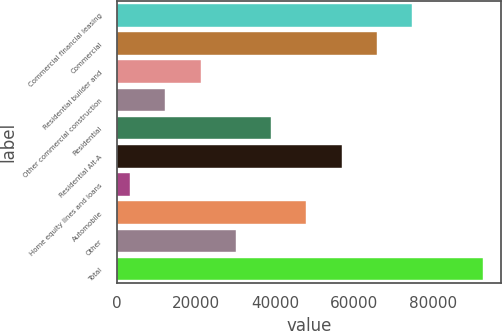<chart> <loc_0><loc_0><loc_500><loc_500><bar_chart><fcel>Commercial financial leasing<fcel>Commercial<fcel>Residential builder and<fcel>Other commercial construction<fcel>Residential<fcel>Residential Alt-A<fcel>Home equity lines and loans<fcel>Automobile<fcel>Other<fcel>Total<nl><fcel>74748.8<fcel>65819.2<fcel>21171.2<fcel>12241.6<fcel>39030.4<fcel>56889.6<fcel>3312<fcel>47960<fcel>30100.8<fcel>92608<nl></chart> 